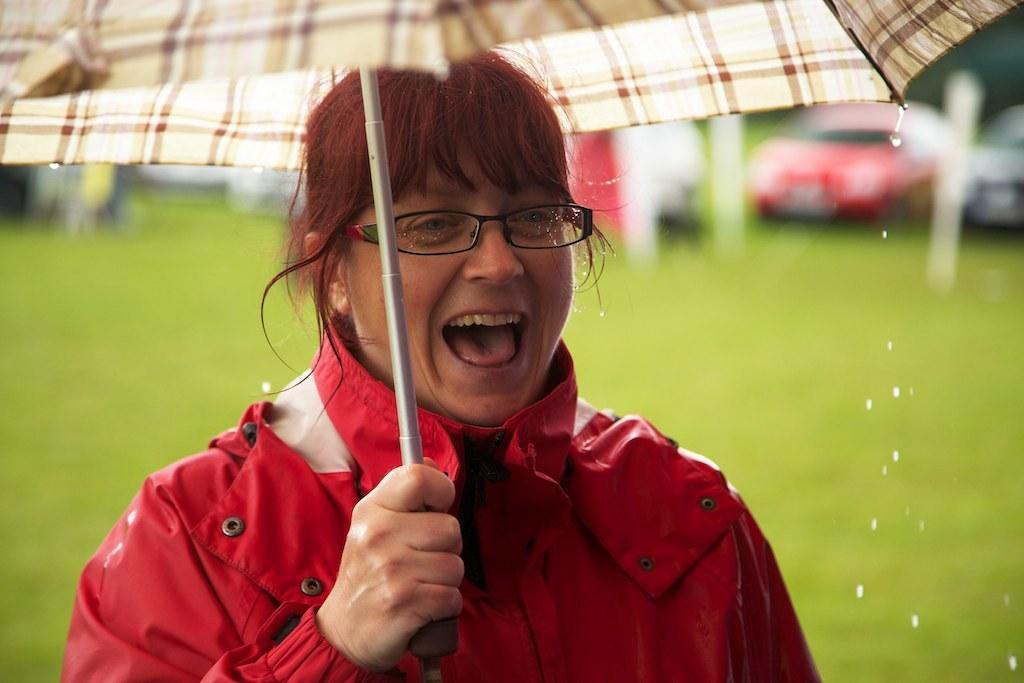Could you give a brief overview of what you see in this image? In this image we can see a person. A person is holding an umbrella. There is a grassy land in the image. There are few vehicles in the image. There is a blur background in the image. 